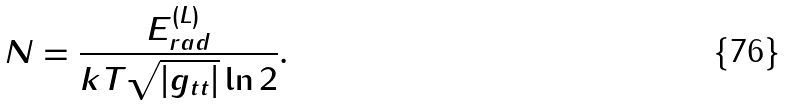Convert formula to latex. <formula><loc_0><loc_0><loc_500><loc_500>N = \frac { E ^ { ( L ) } _ { r a d } } { k T \sqrt { | g _ { t t } | } \ln 2 } .</formula> 